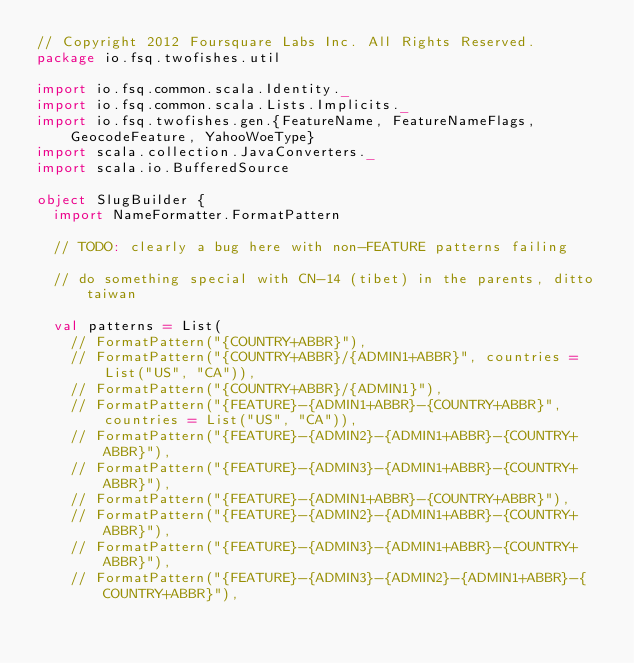<code> <loc_0><loc_0><loc_500><loc_500><_Scala_>// Copyright 2012 Foursquare Labs Inc. All Rights Reserved.
package io.fsq.twofishes.util

import io.fsq.common.scala.Identity._
import io.fsq.common.scala.Lists.Implicits._
import io.fsq.twofishes.gen.{FeatureName, FeatureNameFlags, GeocodeFeature, YahooWoeType}
import scala.collection.JavaConverters._
import scala.io.BufferedSource

object SlugBuilder {
  import NameFormatter.FormatPattern

  // TODO: clearly a bug here with non-FEATURE patterns failing

  // do something special with CN-14 (tibet) in the parents, ditto taiwan

  val patterns = List(
    // FormatPattern("{COUNTRY+ABBR}"),
    // FormatPattern("{COUNTRY+ABBR}/{ADMIN1+ABBR}", countries = List("US", "CA")),
    // FormatPattern("{COUNTRY+ABBR}/{ADMIN1}"),
    // FormatPattern("{FEATURE}-{ADMIN1+ABBR}-{COUNTRY+ABBR}", countries = List("US", "CA")),
    // FormatPattern("{FEATURE}-{ADMIN2}-{ADMIN1+ABBR}-{COUNTRY+ABBR}"),
    // FormatPattern("{FEATURE}-{ADMIN3}-{ADMIN1+ABBR}-{COUNTRY+ABBR}"),
    // FormatPattern("{FEATURE}-{ADMIN1+ABBR}-{COUNTRY+ABBR}"),
    // FormatPattern("{FEATURE}-{ADMIN2}-{ADMIN1+ABBR}-{COUNTRY+ABBR}"),
    // FormatPattern("{FEATURE}-{ADMIN3}-{ADMIN1+ABBR}-{COUNTRY+ABBR}"),
    // FormatPattern("{FEATURE}-{ADMIN3}-{ADMIN2}-{ADMIN1+ABBR}-{COUNTRY+ABBR}"),</code> 